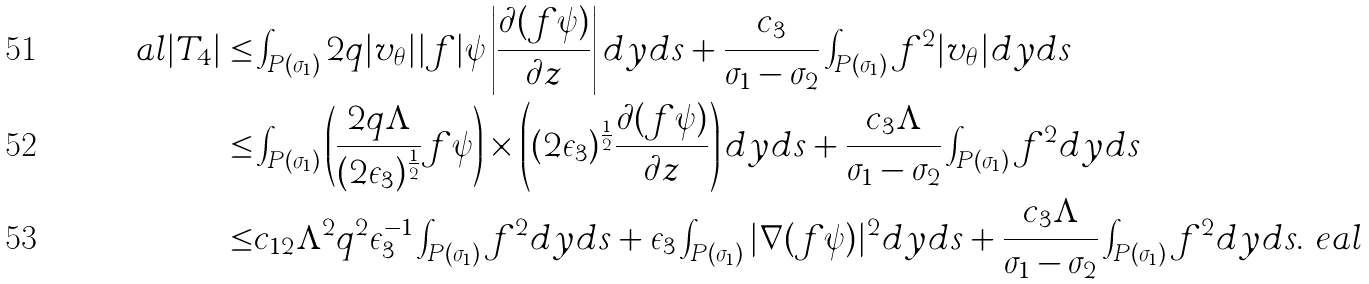Convert formula to latex. <formula><loc_0><loc_0><loc_500><loc_500>\ a l | T _ { 4 } | \leq & \int _ { P ( \sigma _ { 1 } ) } 2 q | v _ { \theta } | | f | \psi \left | \frac { \partial ( f \psi ) } { \partial z } \right | d y d s + \frac { c _ { 3 } } { \sigma _ { 1 } - \sigma _ { 2 } } \int _ { P ( \sigma _ { 1 } ) } f ^ { 2 } | v _ { \theta } | d y d s \\ \leq & \int _ { P ( \sigma _ { 1 } ) } \left ( \frac { 2 q \Lambda } { ( 2 \epsilon _ { 3 } ) ^ { \frac { 1 } { 2 } } } f \psi \right ) \times \left ( ( 2 \epsilon _ { 3 } ) ^ { \frac { 1 } { 2 } } \frac { \partial ( f \psi ) } { \partial z } \right ) d y d s + \frac { c _ { 3 } \Lambda } { \sigma _ { 1 } - \sigma _ { 2 } } \int _ { P ( \sigma _ { 1 } ) } f ^ { 2 } d y d s \\ \leq & c _ { 1 2 } \Lambda ^ { 2 } q ^ { 2 } \epsilon _ { 3 } ^ { - 1 } \int _ { P ( \sigma _ { 1 } ) } f ^ { 2 } d y d s + \epsilon _ { 3 } \int _ { P ( \sigma _ { 1 } ) } | \nabla ( f \psi ) | ^ { 2 } d y d s + \frac { c _ { 3 } \Lambda } { \sigma _ { 1 } - \sigma _ { 2 } } \int _ { P ( \sigma _ { 1 } ) } f ^ { 2 } d y d s . \ e a l</formula> 